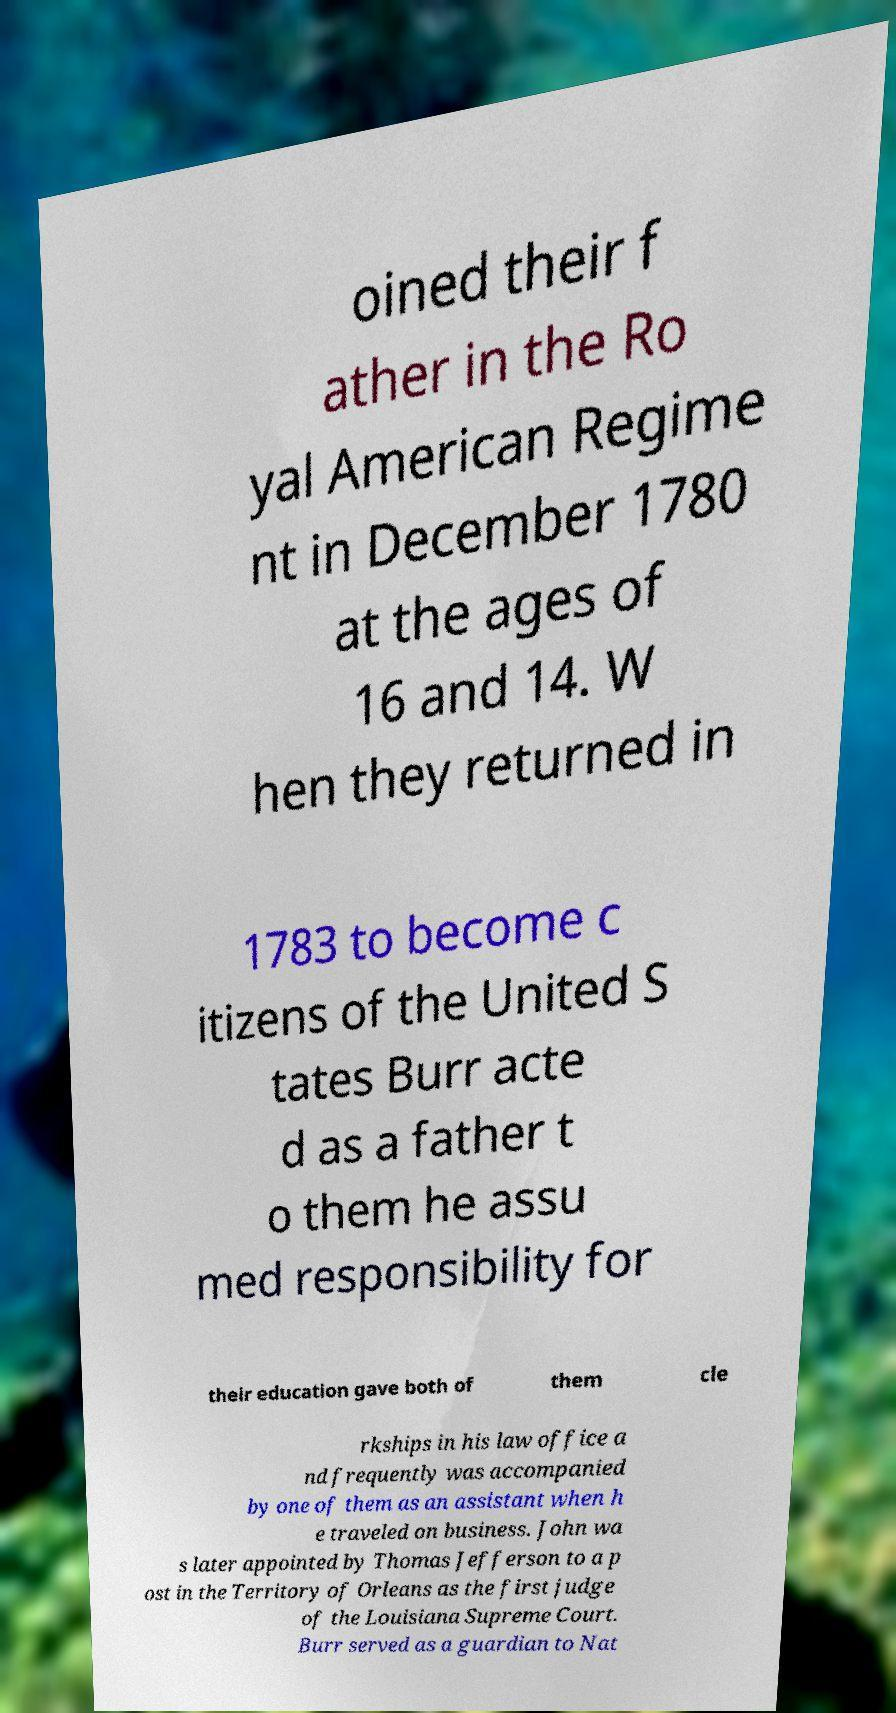Can you accurately transcribe the text from the provided image for me? oined their f ather in the Ro yal American Regime nt in December 1780 at the ages of 16 and 14. W hen they returned in 1783 to become c itizens of the United S tates Burr acte d as a father t o them he assu med responsibility for their education gave both of them cle rkships in his law office a nd frequently was accompanied by one of them as an assistant when h e traveled on business. John wa s later appointed by Thomas Jefferson to a p ost in the Territory of Orleans as the first judge of the Louisiana Supreme Court. Burr served as a guardian to Nat 